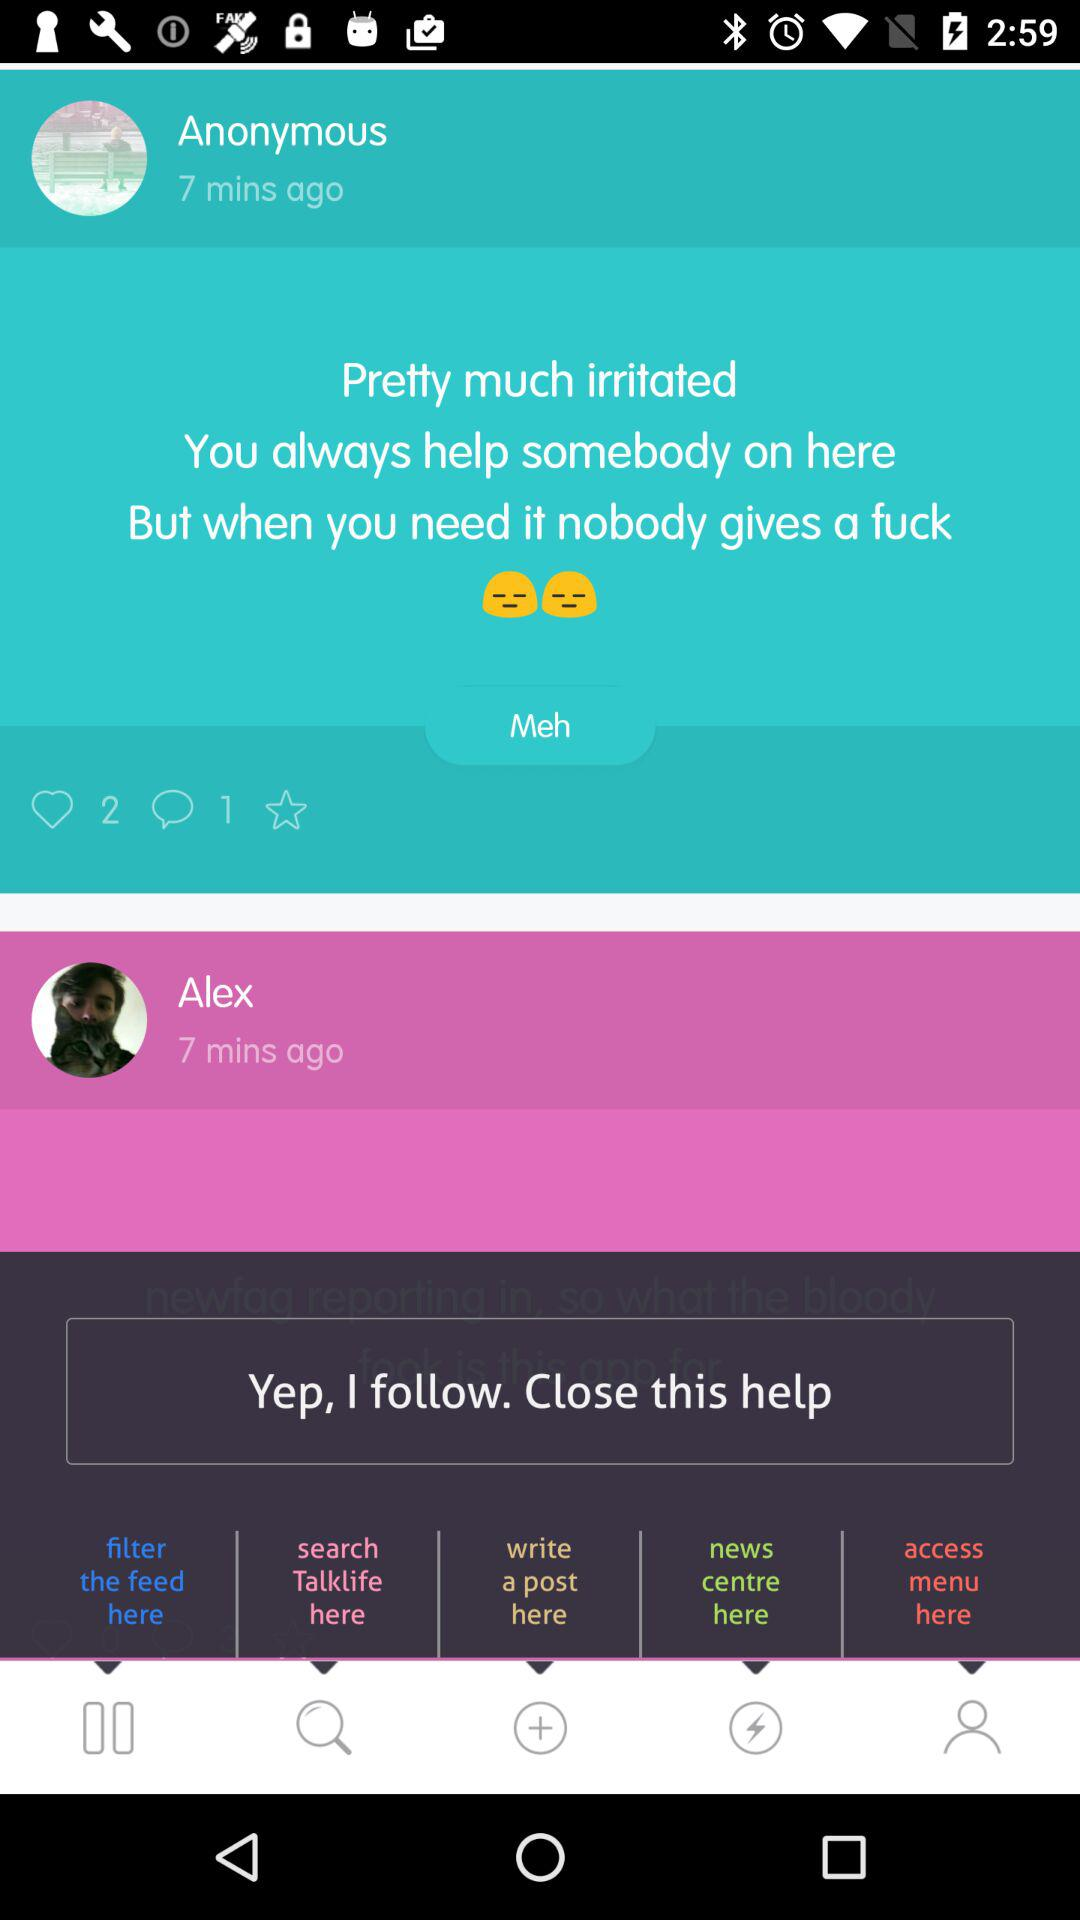How many minutes ago did Anonymous post? Anonymous posted 7 minutes ago. 